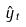<formula> <loc_0><loc_0><loc_500><loc_500>\hat { y } _ { t }</formula> 